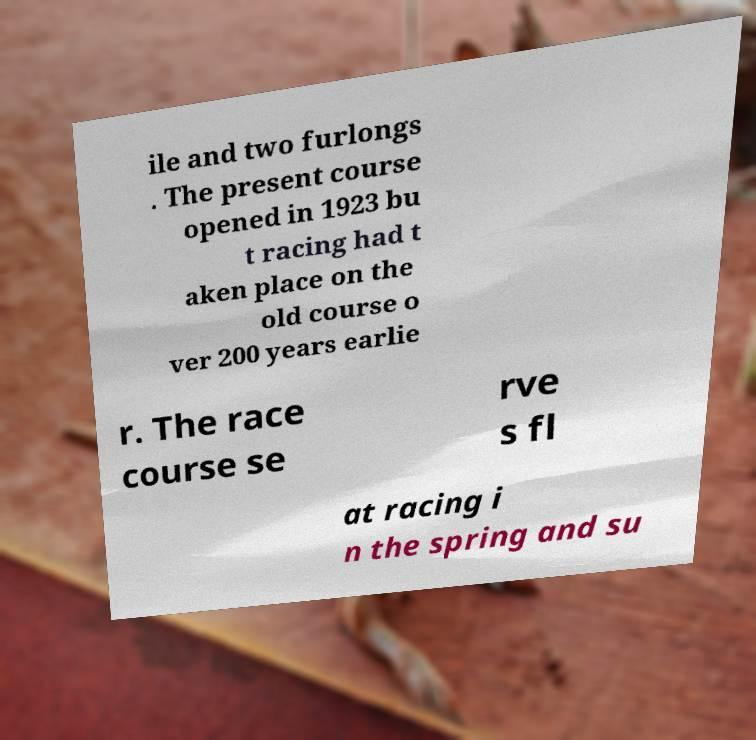For documentation purposes, I need the text within this image transcribed. Could you provide that? ile and two furlongs . The present course opened in 1923 bu t racing had t aken place on the old course o ver 200 years earlie r. The race course se rve s fl at racing i n the spring and su 